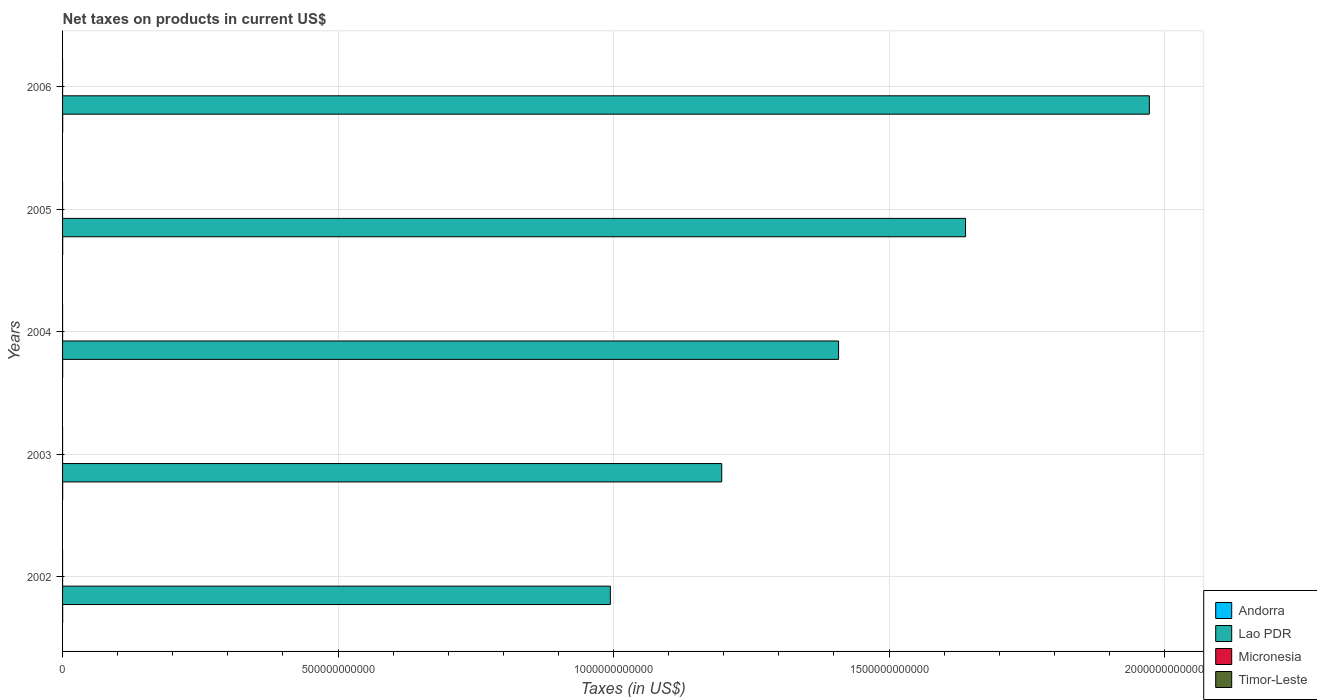How many different coloured bars are there?
Give a very brief answer. 4. How many groups of bars are there?
Give a very brief answer. 5. Are the number of bars per tick equal to the number of legend labels?
Make the answer very short. No. How many bars are there on the 5th tick from the top?
Ensure brevity in your answer.  4. What is the label of the 2nd group of bars from the top?
Your answer should be very brief. 2005. What is the net taxes on products in Andorra in 2005?
Offer a terse response. 2.24e+08. Across all years, what is the maximum net taxes on products in Timor-Leste?
Your answer should be very brief. 1.60e+07. Across all years, what is the minimum net taxes on products in Andorra?
Your response must be concise. 1.66e+08. In which year was the net taxes on products in Micronesia maximum?
Keep it short and to the point. 2005. What is the total net taxes on products in Timor-Leste in the graph?
Keep it short and to the point. 5.50e+07. What is the difference between the net taxes on products in Timor-Leste in 2002 and that in 2005?
Your answer should be compact. 0. What is the difference between the net taxes on products in Lao PDR in 2003 and the net taxes on products in Andorra in 2002?
Your answer should be very brief. 1.20e+12. What is the average net taxes on products in Lao PDR per year?
Provide a short and direct response. 1.44e+12. In the year 2002, what is the difference between the net taxes on products in Micronesia and net taxes on products in Andorra?
Provide a short and direct response. -1.51e+08. In how many years, is the net taxes on products in Micronesia greater than 400000000000 US$?
Your answer should be compact. 0. What is the ratio of the net taxes on products in Andorra in 2002 to that in 2003?
Your response must be concise. 0.95. Is the difference between the net taxes on products in Micronesia in 2002 and 2003 greater than the difference between the net taxes on products in Andorra in 2002 and 2003?
Your response must be concise. Yes. What is the difference between the highest and the second highest net taxes on products in Andorra?
Provide a succinct answer. 1.46e+06. What is the difference between the highest and the lowest net taxes on products in Timor-Leste?
Your answer should be compact. 1.60e+07. In how many years, is the net taxes on products in Lao PDR greater than the average net taxes on products in Lao PDR taken over all years?
Your response must be concise. 2. Is it the case that in every year, the sum of the net taxes on products in Timor-Leste and net taxes on products in Andorra is greater than the sum of net taxes on products in Lao PDR and net taxes on products in Micronesia?
Offer a very short reply. No. How many bars are there?
Provide a short and direct response. 19. Are all the bars in the graph horizontal?
Your response must be concise. Yes. What is the difference between two consecutive major ticks on the X-axis?
Offer a terse response. 5.00e+11. Are the values on the major ticks of X-axis written in scientific E-notation?
Make the answer very short. No. Does the graph contain any zero values?
Provide a short and direct response. Yes. Where does the legend appear in the graph?
Provide a succinct answer. Bottom right. How many legend labels are there?
Offer a terse response. 4. What is the title of the graph?
Make the answer very short. Net taxes on products in current US$. Does "Heavily indebted poor countries" appear as one of the legend labels in the graph?
Offer a very short reply. No. What is the label or title of the X-axis?
Your answer should be compact. Taxes (in US$). What is the label or title of the Y-axis?
Your answer should be compact. Years. What is the Taxes (in US$) of Andorra in 2002?
Your response must be concise. 1.66e+08. What is the Taxes (in US$) of Lao PDR in 2002?
Provide a succinct answer. 9.94e+11. What is the Taxes (in US$) of Micronesia in 2002?
Make the answer very short. 1.42e+07. What is the Taxes (in US$) of Timor-Leste in 2002?
Provide a short and direct response. 1.20e+07. What is the Taxes (in US$) in Andorra in 2003?
Make the answer very short. 1.74e+08. What is the Taxes (in US$) of Lao PDR in 2003?
Your answer should be very brief. 1.20e+12. What is the Taxes (in US$) of Micronesia in 2003?
Provide a short and direct response. 1.67e+07. What is the Taxes (in US$) of Timor-Leste in 2003?
Provide a short and direct response. 1.50e+07. What is the Taxes (in US$) in Andorra in 2004?
Make the answer very short. 2.00e+08. What is the Taxes (in US$) in Lao PDR in 2004?
Provide a succinct answer. 1.41e+12. What is the Taxes (in US$) in Micronesia in 2004?
Ensure brevity in your answer.  1.77e+07. What is the Taxes (in US$) of Timor-Leste in 2004?
Ensure brevity in your answer.  1.60e+07. What is the Taxes (in US$) of Andorra in 2005?
Provide a short and direct response. 2.24e+08. What is the Taxes (in US$) in Lao PDR in 2005?
Your response must be concise. 1.64e+12. What is the Taxes (in US$) in Micronesia in 2005?
Keep it short and to the point. 2.14e+07. What is the Taxes (in US$) of Timor-Leste in 2005?
Give a very brief answer. 1.20e+07. What is the Taxes (in US$) of Andorra in 2006?
Give a very brief answer. 2.23e+08. What is the Taxes (in US$) of Lao PDR in 2006?
Provide a short and direct response. 1.97e+12. What is the Taxes (in US$) of Micronesia in 2006?
Your response must be concise. 2.11e+07. Across all years, what is the maximum Taxes (in US$) in Andorra?
Your answer should be compact. 2.24e+08. Across all years, what is the maximum Taxes (in US$) in Lao PDR?
Make the answer very short. 1.97e+12. Across all years, what is the maximum Taxes (in US$) of Micronesia?
Keep it short and to the point. 2.14e+07. Across all years, what is the maximum Taxes (in US$) in Timor-Leste?
Provide a short and direct response. 1.60e+07. Across all years, what is the minimum Taxes (in US$) in Andorra?
Provide a short and direct response. 1.66e+08. Across all years, what is the minimum Taxes (in US$) of Lao PDR?
Give a very brief answer. 9.94e+11. Across all years, what is the minimum Taxes (in US$) in Micronesia?
Ensure brevity in your answer.  1.42e+07. What is the total Taxes (in US$) of Andorra in the graph?
Make the answer very short. 9.86e+08. What is the total Taxes (in US$) in Lao PDR in the graph?
Offer a very short reply. 7.21e+12. What is the total Taxes (in US$) in Micronesia in the graph?
Provide a short and direct response. 9.11e+07. What is the total Taxes (in US$) in Timor-Leste in the graph?
Your answer should be very brief. 5.50e+07. What is the difference between the Taxes (in US$) in Andorra in 2002 and that in 2003?
Provide a succinct answer. -8.15e+06. What is the difference between the Taxes (in US$) of Lao PDR in 2002 and that in 2003?
Provide a short and direct response. -2.02e+11. What is the difference between the Taxes (in US$) in Micronesia in 2002 and that in 2003?
Ensure brevity in your answer.  -2.51e+06. What is the difference between the Taxes (in US$) in Andorra in 2002 and that in 2004?
Keep it short and to the point. -3.42e+07. What is the difference between the Taxes (in US$) in Lao PDR in 2002 and that in 2004?
Your answer should be compact. -4.14e+11. What is the difference between the Taxes (in US$) of Micronesia in 2002 and that in 2004?
Offer a very short reply. -3.50e+06. What is the difference between the Taxes (in US$) in Timor-Leste in 2002 and that in 2004?
Provide a succinct answer. -4.00e+06. What is the difference between the Taxes (in US$) in Andorra in 2002 and that in 2005?
Offer a very short reply. -5.84e+07. What is the difference between the Taxes (in US$) of Lao PDR in 2002 and that in 2005?
Offer a very short reply. -6.45e+11. What is the difference between the Taxes (in US$) of Micronesia in 2002 and that in 2005?
Your response must be concise. -7.13e+06. What is the difference between the Taxes (in US$) of Andorra in 2002 and that in 2006?
Offer a very short reply. -5.69e+07. What is the difference between the Taxes (in US$) of Lao PDR in 2002 and that in 2006?
Your answer should be very brief. -9.78e+11. What is the difference between the Taxes (in US$) in Micronesia in 2002 and that in 2006?
Offer a terse response. -6.87e+06. What is the difference between the Taxes (in US$) of Andorra in 2003 and that in 2004?
Your response must be concise. -2.60e+07. What is the difference between the Taxes (in US$) in Lao PDR in 2003 and that in 2004?
Provide a succinct answer. -2.12e+11. What is the difference between the Taxes (in US$) in Micronesia in 2003 and that in 2004?
Your answer should be compact. -9.89e+05. What is the difference between the Taxes (in US$) in Timor-Leste in 2003 and that in 2004?
Make the answer very short. -1.00e+06. What is the difference between the Taxes (in US$) in Andorra in 2003 and that in 2005?
Give a very brief answer. -5.02e+07. What is the difference between the Taxes (in US$) of Lao PDR in 2003 and that in 2005?
Your answer should be very brief. -4.43e+11. What is the difference between the Taxes (in US$) in Micronesia in 2003 and that in 2005?
Ensure brevity in your answer.  -4.62e+06. What is the difference between the Taxes (in US$) of Andorra in 2003 and that in 2006?
Your answer should be very brief. -4.88e+07. What is the difference between the Taxes (in US$) of Lao PDR in 2003 and that in 2006?
Provide a succinct answer. -7.76e+11. What is the difference between the Taxes (in US$) of Micronesia in 2003 and that in 2006?
Your response must be concise. -4.36e+06. What is the difference between the Taxes (in US$) of Andorra in 2004 and that in 2005?
Make the answer very short. -2.42e+07. What is the difference between the Taxes (in US$) of Lao PDR in 2004 and that in 2005?
Offer a very short reply. -2.30e+11. What is the difference between the Taxes (in US$) in Micronesia in 2004 and that in 2005?
Keep it short and to the point. -3.63e+06. What is the difference between the Taxes (in US$) of Andorra in 2004 and that in 2006?
Provide a succinct answer. -2.28e+07. What is the difference between the Taxes (in US$) of Lao PDR in 2004 and that in 2006?
Keep it short and to the point. -5.64e+11. What is the difference between the Taxes (in US$) of Micronesia in 2004 and that in 2006?
Make the answer very short. -3.38e+06. What is the difference between the Taxes (in US$) in Andorra in 2005 and that in 2006?
Your answer should be very brief. 1.46e+06. What is the difference between the Taxes (in US$) in Lao PDR in 2005 and that in 2006?
Your answer should be very brief. -3.34e+11. What is the difference between the Taxes (in US$) of Micronesia in 2005 and that in 2006?
Provide a short and direct response. 2.57e+05. What is the difference between the Taxes (in US$) in Andorra in 2002 and the Taxes (in US$) in Lao PDR in 2003?
Give a very brief answer. -1.20e+12. What is the difference between the Taxes (in US$) of Andorra in 2002 and the Taxes (in US$) of Micronesia in 2003?
Ensure brevity in your answer.  1.49e+08. What is the difference between the Taxes (in US$) of Andorra in 2002 and the Taxes (in US$) of Timor-Leste in 2003?
Offer a very short reply. 1.51e+08. What is the difference between the Taxes (in US$) of Lao PDR in 2002 and the Taxes (in US$) of Micronesia in 2003?
Your answer should be very brief. 9.94e+11. What is the difference between the Taxes (in US$) of Lao PDR in 2002 and the Taxes (in US$) of Timor-Leste in 2003?
Provide a short and direct response. 9.94e+11. What is the difference between the Taxes (in US$) of Micronesia in 2002 and the Taxes (in US$) of Timor-Leste in 2003?
Provide a succinct answer. -7.73e+05. What is the difference between the Taxes (in US$) of Andorra in 2002 and the Taxes (in US$) of Lao PDR in 2004?
Your answer should be compact. -1.41e+12. What is the difference between the Taxes (in US$) of Andorra in 2002 and the Taxes (in US$) of Micronesia in 2004?
Offer a terse response. 1.48e+08. What is the difference between the Taxes (in US$) in Andorra in 2002 and the Taxes (in US$) in Timor-Leste in 2004?
Provide a short and direct response. 1.50e+08. What is the difference between the Taxes (in US$) of Lao PDR in 2002 and the Taxes (in US$) of Micronesia in 2004?
Keep it short and to the point. 9.94e+11. What is the difference between the Taxes (in US$) of Lao PDR in 2002 and the Taxes (in US$) of Timor-Leste in 2004?
Your response must be concise. 9.94e+11. What is the difference between the Taxes (in US$) in Micronesia in 2002 and the Taxes (in US$) in Timor-Leste in 2004?
Provide a short and direct response. -1.77e+06. What is the difference between the Taxes (in US$) in Andorra in 2002 and the Taxes (in US$) in Lao PDR in 2005?
Make the answer very short. -1.64e+12. What is the difference between the Taxes (in US$) in Andorra in 2002 and the Taxes (in US$) in Micronesia in 2005?
Provide a short and direct response. 1.44e+08. What is the difference between the Taxes (in US$) of Andorra in 2002 and the Taxes (in US$) of Timor-Leste in 2005?
Provide a short and direct response. 1.54e+08. What is the difference between the Taxes (in US$) in Lao PDR in 2002 and the Taxes (in US$) in Micronesia in 2005?
Offer a very short reply. 9.94e+11. What is the difference between the Taxes (in US$) in Lao PDR in 2002 and the Taxes (in US$) in Timor-Leste in 2005?
Provide a succinct answer. 9.94e+11. What is the difference between the Taxes (in US$) of Micronesia in 2002 and the Taxes (in US$) of Timor-Leste in 2005?
Provide a succinct answer. 2.23e+06. What is the difference between the Taxes (in US$) in Andorra in 2002 and the Taxes (in US$) in Lao PDR in 2006?
Make the answer very short. -1.97e+12. What is the difference between the Taxes (in US$) of Andorra in 2002 and the Taxes (in US$) of Micronesia in 2006?
Provide a succinct answer. 1.45e+08. What is the difference between the Taxes (in US$) in Lao PDR in 2002 and the Taxes (in US$) in Micronesia in 2006?
Offer a terse response. 9.94e+11. What is the difference between the Taxes (in US$) of Andorra in 2003 and the Taxes (in US$) of Lao PDR in 2004?
Offer a very short reply. -1.41e+12. What is the difference between the Taxes (in US$) of Andorra in 2003 and the Taxes (in US$) of Micronesia in 2004?
Offer a terse response. 1.56e+08. What is the difference between the Taxes (in US$) in Andorra in 2003 and the Taxes (in US$) in Timor-Leste in 2004?
Your answer should be very brief. 1.58e+08. What is the difference between the Taxes (in US$) of Lao PDR in 2003 and the Taxes (in US$) of Micronesia in 2004?
Offer a very short reply. 1.20e+12. What is the difference between the Taxes (in US$) of Lao PDR in 2003 and the Taxes (in US$) of Timor-Leste in 2004?
Provide a short and direct response. 1.20e+12. What is the difference between the Taxes (in US$) of Micronesia in 2003 and the Taxes (in US$) of Timor-Leste in 2004?
Give a very brief answer. 7.35e+05. What is the difference between the Taxes (in US$) in Andorra in 2003 and the Taxes (in US$) in Lao PDR in 2005?
Give a very brief answer. -1.64e+12. What is the difference between the Taxes (in US$) of Andorra in 2003 and the Taxes (in US$) of Micronesia in 2005?
Give a very brief answer. 1.52e+08. What is the difference between the Taxes (in US$) in Andorra in 2003 and the Taxes (in US$) in Timor-Leste in 2005?
Offer a very short reply. 1.62e+08. What is the difference between the Taxes (in US$) in Lao PDR in 2003 and the Taxes (in US$) in Micronesia in 2005?
Your answer should be very brief. 1.20e+12. What is the difference between the Taxes (in US$) in Lao PDR in 2003 and the Taxes (in US$) in Timor-Leste in 2005?
Provide a short and direct response. 1.20e+12. What is the difference between the Taxes (in US$) of Micronesia in 2003 and the Taxes (in US$) of Timor-Leste in 2005?
Your answer should be compact. 4.73e+06. What is the difference between the Taxes (in US$) of Andorra in 2003 and the Taxes (in US$) of Lao PDR in 2006?
Make the answer very short. -1.97e+12. What is the difference between the Taxes (in US$) in Andorra in 2003 and the Taxes (in US$) in Micronesia in 2006?
Provide a succinct answer. 1.53e+08. What is the difference between the Taxes (in US$) in Lao PDR in 2003 and the Taxes (in US$) in Micronesia in 2006?
Provide a succinct answer. 1.20e+12. What is the difference between the Taxes (in US$) in Andorra in 2004 and the Taxes (in US$) in Lao PDR in 2005?
Your response must be concise. -1.64e+12. What is the difference between the Taxes (in US$) in Andorra in 2004 and the Taxes (in US$) in Micronesia in 2005?
Your answer should be compact. 1.78e+08. What is the difference between the Taxes (in US$) of Andorra in 2004 and the Taxes (in US$) of Timor-Leste in 2005?
Your answer should be very brief. 1.88e+08. What is the difference between the Taxes (in US$) in Lao PDR in 2004 and the Taxes (in US$) in Micronesia in 2005?
Provide a short and direct response. 1.41e+12. What is the difference between the Taxes (in US$) in Lao PDR in 2004 and the Taxes (in US$) in Timor-Leste in 2005?
Ensure brevity in your answer.  1.41e+12. What is the difference between the Taxes (in US$) of Micronesia in 2004 and the Taxes (in US$) of Timor-Leste in 2005?
Your response must be concise. 5.72e+06. What is the difference between the Taxes (in US$) in Andorra in 2004 and the Taxes (in US$) in Lao PDR in 2006?
Make the answer very short. -1.97e+12. What is the difference between the Taxes (in US$) in Andorra in 2004 and the Taxes (in US$) in Micronesia in 2006?
Offer a very short reply. 1.79e+08. What is the difference between the Taxes (in US$) in Lao PDR in 2004 and the Taxes (in US$) in Micronesia in 2006?
Offer a very short reply. 1.41e+12. What is the difference between the Taxes (in US$) in Andorra in 2005 and the Taxes (in US$) in Lao PDR in 2006?
Make the answer very short. -1.97e+12. What is the difference between the Taxes (in US$) in Andorra in 2005 and the Taxes (in US$) in Micronesia in 2006?
Make the answer very short. 2.03e+08. What is the difference between the Taxes (in US$) in Lao PDR in 2005 and the Taxes (in US$) in Micronesia in 2006?
Your answer should be compact. 1.64e+12. What is the average Taxes (in US$) of Andorra per year?
Offer a very short reply. 1.97e+08. What is the average Taxes (in US$) in Lao PDR per year?
Your answer should be compact. 1.44e+12. What is the average Taxes (in US$) of Micronesia per year?
Offer a very short reply. 1.82e+07. What is the average Taxes (in US$) in Timor-Leste per year?
Make the answer very short. 1.10e+07. In the year 2002, what is the difference between the Taxes (in US$) of Andorra and Taxes (in US$) of Lao PDR?
Your response must be concise. -9.94e+11. In the year 2002, what is the difference between the Taxes (in US$) of Andorra and Taxes (in US$) of Micronesia?
Your response must be concise. 1.51e+08. In the year 2002, what is the difference between the Taxes (in US$) of Andorra and Taxes (in US$) of Timor-Leste?
Make the answer very short. 1.54e+08. In the year 2002, what is the difference between the Taxes (in US$) of Lao PDR and Taxes (in US$) of Micronesia?
Offer a very short reply. 9.94e+11. In the year 2002, what is the difference between the Taxes (in US$) in Lao PDR and Taxes (in US$) in Timor-Leste?
Your answer should be very brief. 9.94e+11. In the year 2002, what is the difference between the Taxes (in US$) of Micronesia and Taxes (in US$) of Timor-Leste?
Ensure brevity in your answer.  2.23e+06. In the year 2003, what is the difference between the Taxes (in US$) of Andorra and Taxes (in US$) of Lao PDR?
Your response must be concise. -1.20e+12. In the year 2003, what is the difference between the Taxes (in US$) of Andorra and Taxes (in US$) of Micronesia?
Provide a succinct answer. 1.57e+08. In the year 2003, what is the difference between the Taxes (in US$) of Andorra and Taxes (in US$) of Timor-Leste?
Your answer should be compact. 1.59e+08. In the year 2003, what is the difference between the Taxes (in US$) of Lao PDR and Taxes (in US$) of Micronesia?
Your answer should be very brief. 1.20e+12. In the year 2003, what is the difference between the Taxes (in US$) of Lao PDR and Taxes (in US$) of Timor-Leste?
Your response must be concise. 1.20e+12. In the year 2003, what is the difference between the Taxes (in US$) of Micronesia and Taxes (in US$) of Timor-Leste?
Provide a succinct answer. 1.73e+06. In the year 2004, what is the difference between the Taxes (in US$) in Andorra and Taxes (in US$) in Lao PDR?
Ensure brevity in your answer.  -1.41e+12. In the year 2004, what is the difference between the Taxes (in US$) of Andorra and Taxes (in US$) of Micronesia?
Offer a terse response. 1.82e+08. In the year 2004, what is the difference between the Taxes (in US$) of Andorra and Taxes (in US$) of Timor-Leste?
Keep it short and to the point. 1.84e+08. In the year 2004, what is the difference between the Taxes (in US$) of Lao PDR and Taxes (in US$) of Micronesia?
Keep it short and to the point. 1.41e+12. In the year 2004, what is the difference between the Taxes (in US$) in Lao PDR and Taxes (in US$) in Timor-Leste?
Your answer should be very brief. 1.41e+12. In the year 2004, what is the difference between the Taxes (in US$) in Micronesia and Taxes (in US$) in Timor-Leste?
Offer a terse response. 1.72e+06. In the year 2005, what is the difference between the Taxes (in US$) in Andorra and Taxes (in US$) in Lao PDR?
Ensure brevity in your answer.  -1.64e+12. In the year 2005, what is the difference between the Taxes (in US$) in Andorra and Taxes (in US$) in Micronesia?
Keep it short and to the point. 2.03e+08. In the year 2005, what is the difference between the Taxes (in US$) of Andorra and Taxes (in US$) of Timor-Leste?
Your answer should be compact. 2.12e+08. In the year 2005, what is the difference between the Taxes (in US$) of Lao PDR and Taxes (in US$) of Micronesia?
Provide a succinct answer. 1.64e+12. In the year 2005, what is the difference between the Taxes (in US$) of Lao PDR and Taxes (in US$) of Timor-Leste?
Provide a short and direct response. 1.64e+12. In the year 2005, what is the difference between the Taxes (in US$) in Micronesia and Taxes (in US$) in Timor-Leste?
Keep it short and to the point. 9.36e+06. In the year 2006, what is the difference between the Taxes (in US$) in Andorra and Taxes (in US$) in Lao PDR?
Ensure brevity in your answer.  -1.97e+12. In the year 2006, what is the difference between the Taxes (in US$) in Andorra and Taxes (in US$) in Micronesia?
Provide a succinct answer. 2.01e+08. In the year 2006, what is the difference between the Taxes (in US$) in Lao PDR and Taxes (in US$) in Micronesia?
Offer a very short reply. 1.97e+12. What is the ratio of the Taxes (in US$) in Andorra in 2002 to that in 2003?
Provide a succinct answer. 0.95. What is the ratio of the Taxes (in US$) of Lao PDR in 2002 to that in 2003?
Your answer should be compact. 0.83. What is the ratio of the Taxes (in US$) of Micronesia in 2002 to that in 2003?
Offer a very short reply. 0.85. What is the ratio of the Taxes (in US$) in Andorra in 2002 to that in 2004?
Offer a terse response. 0.83. What is the ratio of the Taxes (in US$) in Lao PDR in 2002 to that in 2004?
Your response must be concise. 0.71. What is the ratio of the Taxes (in US$) of Micronesia in 2002 to that in 2004?
Your answer should be compact. 0.8. What is the ratio of the Taxes (in US$) of Andorra in 2002 to that in 2005?
Provide a succinct answer. 0.74. What is the ratio of the Taxes (in US$) of Lao PDR in 2002 to that in 2005?
Your answer should be compact. 0.61. What is the ratio of the Taxes (in US$) of Micronesia in 2002 to that in 2005?
Make the answer very short. 0.67. What is the ratio of the Taxes (in US$) in Andorra in 2002 to that in 2006?
Offer a very short reply. 0.74. What is the ratio of the Taxes (in US$) of Lao PDR in 2002 to that in 2006?
Give a very brief answer. 0.5. What is the ratio of the Taxes (in US$) in Micronesia in 2002 to that in 2006?
Ensure brevity in your answer.  0.67. What is the ratio of the Taxes (in US$) of Andorra in 2003 to that in 2004?
Ensure brevity in your answer.  0.87. What is the ratio of the Taxes (in US$) in Lao PDR in 2003 to that in 2004?
Provide a short and direct response. 0.85. What is the ratio of the Taxes (in US$) of Micronesia in 2003 to that in 2004?
Your response must be concise. 0.94. What is the ratio of the Taxes (in US$) of Timor-Leste in 2003 to that in 2004?
Offer a very short reply. 0.94. What is the ratio of the Taxes (in US$) of Andorra in 2003 to that in 2005?
Give a very brief answer. 0.78. What is the ratio of the Taxes (in US$) of Lao PDR in 2003 to that in 2005?
Give a very brief answer. 0.73. What is the ratio of the Taxes (in US$) of Micronesia in 2003 to that in 2005?
Provide a short and direct response. 0.78. What is the ratio of the Taxes (in US$) in Andorra in 2003 to that in 2006?
Your response must be concise. 0.78. What is the ratio of the Taxes (in US$) of Lao PDR in 2003 to that in 2006?
Provide a short and direct response. 0.61. What is the ratio of the Taxes (in US$) of Micronesia in 2003 to that in 2006?
Your response must be concise. 0.79. What is the ratio of the Taxes (in US$) of Andorra in 2004 to that in 2005?
Provide a succinct answer. 0.89. What is the ratio of the Taxes (in US$) in Lao PDR in 2004 to that in 2005?
Ensure brevity in your answer.  0.86. What is the ratio of the Taxes (in US$) in Micronesia in 2004 to that in 2005?
Your response must be concise. 0.83. What is the ratio of the Taxes (in US$) of Andorra in 2004 to that in 2006?
Offer a very short reply. 0.9. What is the ratio of the Taxes (in US$) in Lao PDR in 2004 to that in 2006?
Provide a succinct answer. 0.71. What is the ratio of the Taxes (in US$) of Micronesia in 2004 to that in 2006?
Provide a short and direct response. 0.84. What is the ratio of the Taxes (in US$) of Andorra in 2005 to that in 2006?
Provide a short and direct response. 1.01. What is the ratio of the Taxes (in US$) of Lao PDR in 2005 to that in 2006?
Provide a short and direct response. 0.83. What is the ratio of the Taxes (in US$) of Micronesia in 2005 to that in 2006?
Your answer should be compact. 1.01. What is the difference between the highest and the second highest Taxes (in US$) in Andorra?
Your response must be concise. 1.46e+06. What is the difference between the highest and the second highest Taxes (in US$) of Lao PDR?
Offer a very short reply. 3.34e+11. What is the difference between the highest and the second highest Taxes (in US$) in Micronesia?
Offer a very short reply. 2.57e+05. What is the difference between the highest and the second highest Taxes (in US$) of Timor-Leste?
Make the answer very short. 1.00e+06. What is the difference between the highest and the lowest Taxes (in US$) of Andorra?
Offer a terse response. 5.84e+07. What is the difference between the highest and the lowest Taxes (in US$) of Lao PDR?
Your answer should be compact. 9.78e+11. What is the difference between the highest and the lowest Taxes (in US$) of Micronesia?
Offer a very short reply. 7.13e+06. What is the difference between the highest and the lowest Taxes (in US$) of Timor-Leste?
Provide a succinct answer. 1.60e+07. 